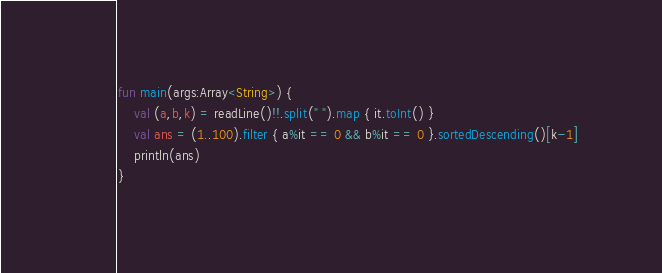Convert code to text. <code><loc_0><loc_0><loc_500><loc_500><_Kotlin_>fun main(args:Array<String>) {
    val (a,b,k) = readLine()!!.split(" ").map { it.toInt() }
    val ans = (1..100).filter { a%it == 0 && b%it == 0 }.sortedDescending()[k-1]
    println(ans)
}


</code> 